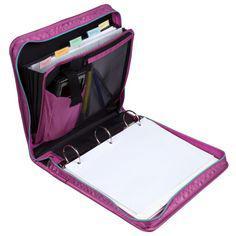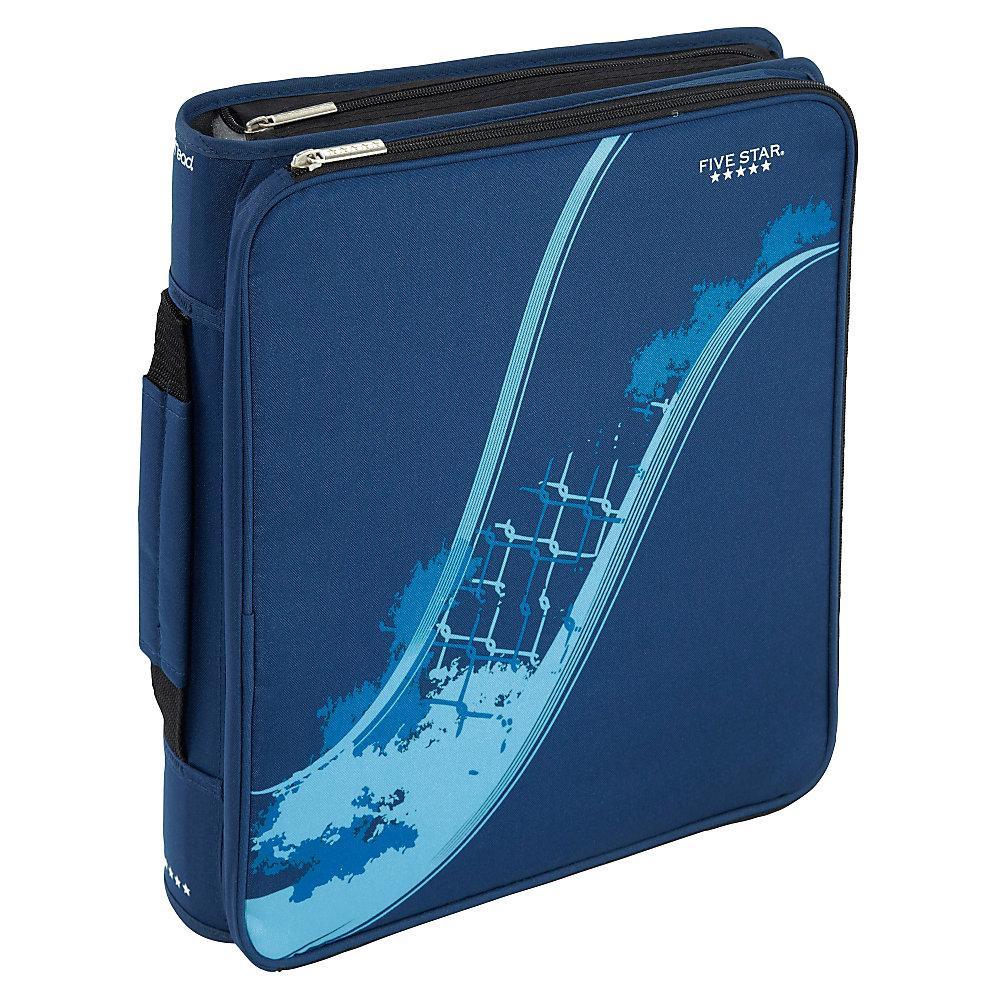The first image is the image on the left, the second image is the image on the right. Examine the images to the left and right. Is the description "One zipper binder is unzipped and open so that at least one set of three notebook rings and multiple interior pockets are visible." accurate? Answer yes or no. Yes. The first image is the image on the left, the second image is the image on the right. Given the left and right images, does the statement "The left image shows only one binder, which is purplish in color." hold true? Answer yes or no. Yes. 